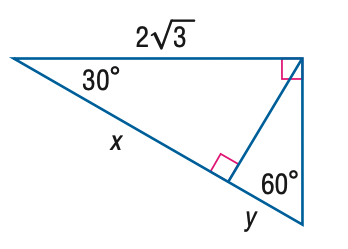Question: Find x.
Choices:
A. \sqrt { 3 }
B. \sqrt { 6 }
C. 3
D. 6
Answer with the letter. Answer: C Question: Find y.
Choices:
A. \frac { \sqrt { 3 } } { 3 }
B. 1
C. \sqrt { 3 }
D. 3
Answer with the letter. Answer: B 